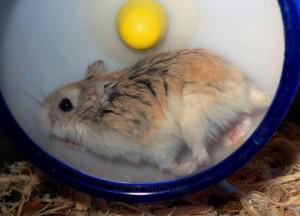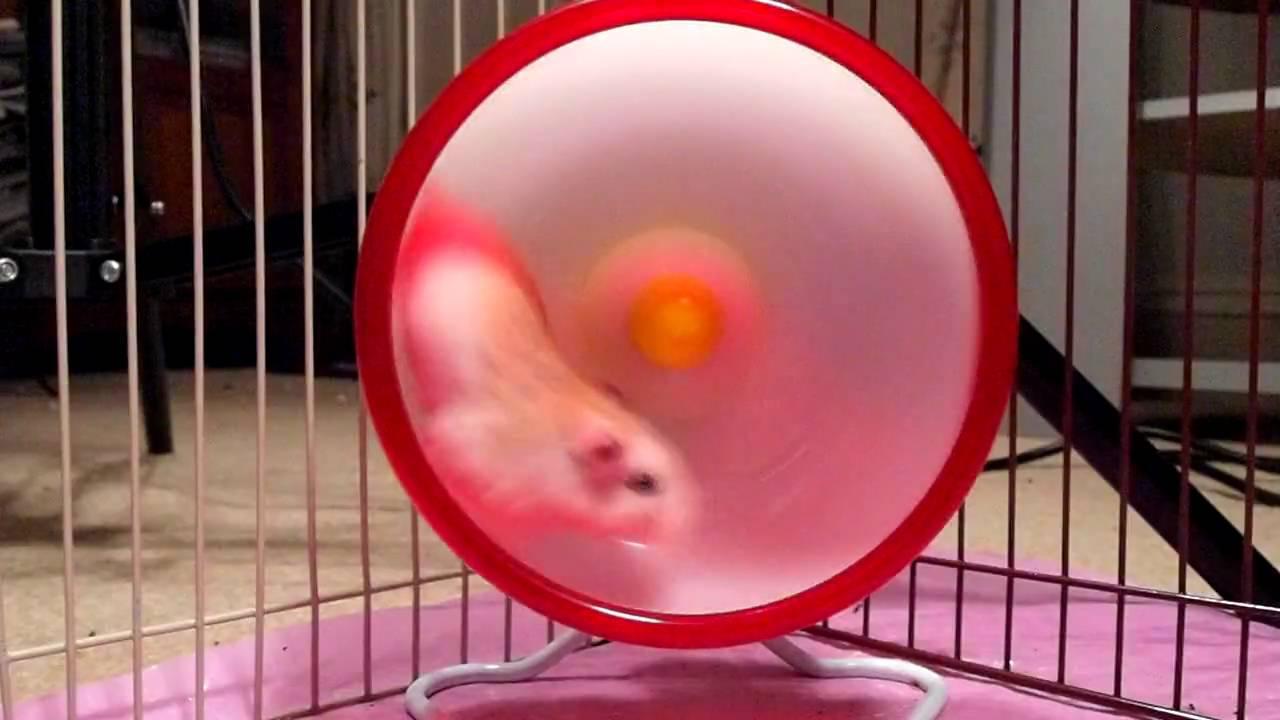The first image is the image on the left, the second image is the image on the right. Examine the images to the left and right. Is the description "The left image contains a rodent running on a blue hamster wheel." accurate? Answer yes or no. Yes. The first image is the image on the left, the second image is the image on the right. For the images shown, is this caption "Each image features at least one pet rodent in a wheel, and the wheel on the left is blue while the one on the right is red." true? Answer yes or no. Yes. 